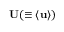Convert formula to latex. <formula><loc_0><loc_0><loc_500><loc_500>{ U } ( \equiv \langle { u } \rangle )</formula> 